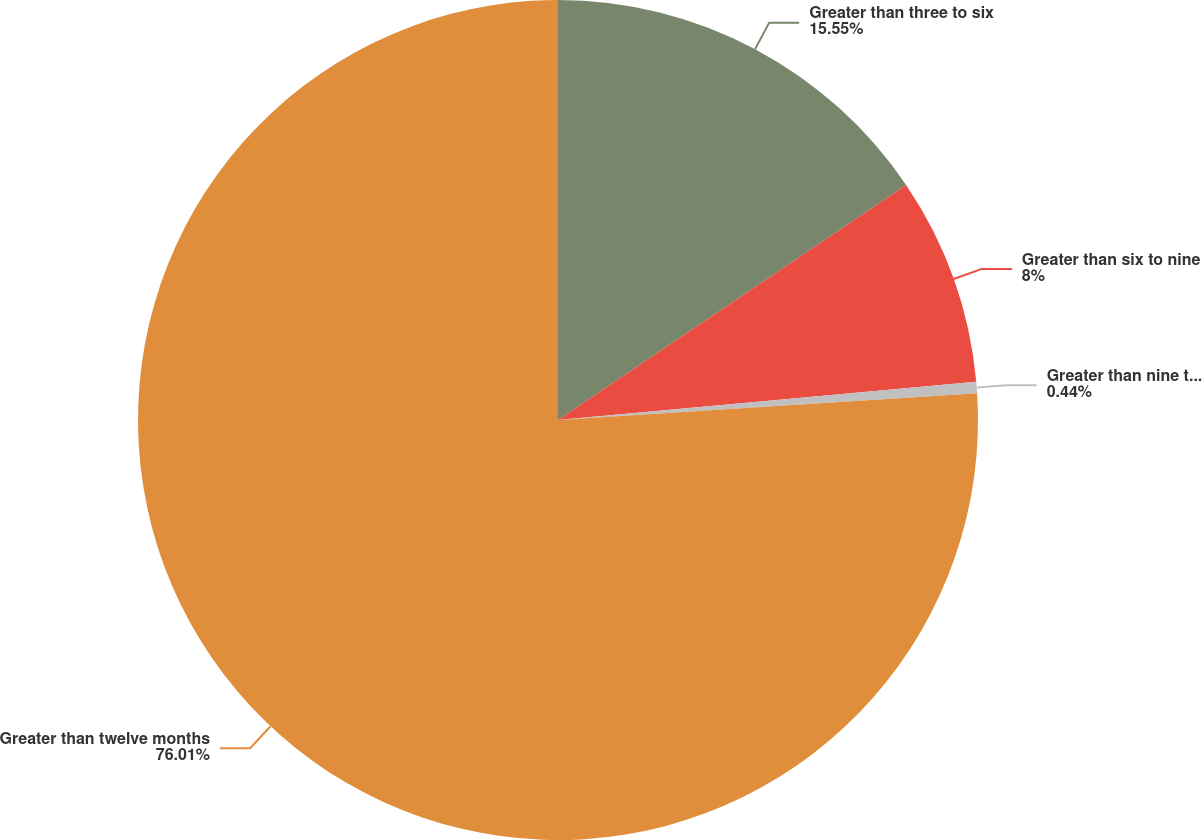Convert chart to OTSL. <chart><loc_0><loc_0><loc_500><loc_500><pie_chart><fcel>Greater than three to six<fcel>Greater than six to nine<fcel>Greater than nine toeleven<fcel>Greater than twelve months<nl><fcel>15.55%<fcel>8.0%<fcel>0.44%<fcel>76.01%<nl></chart> 